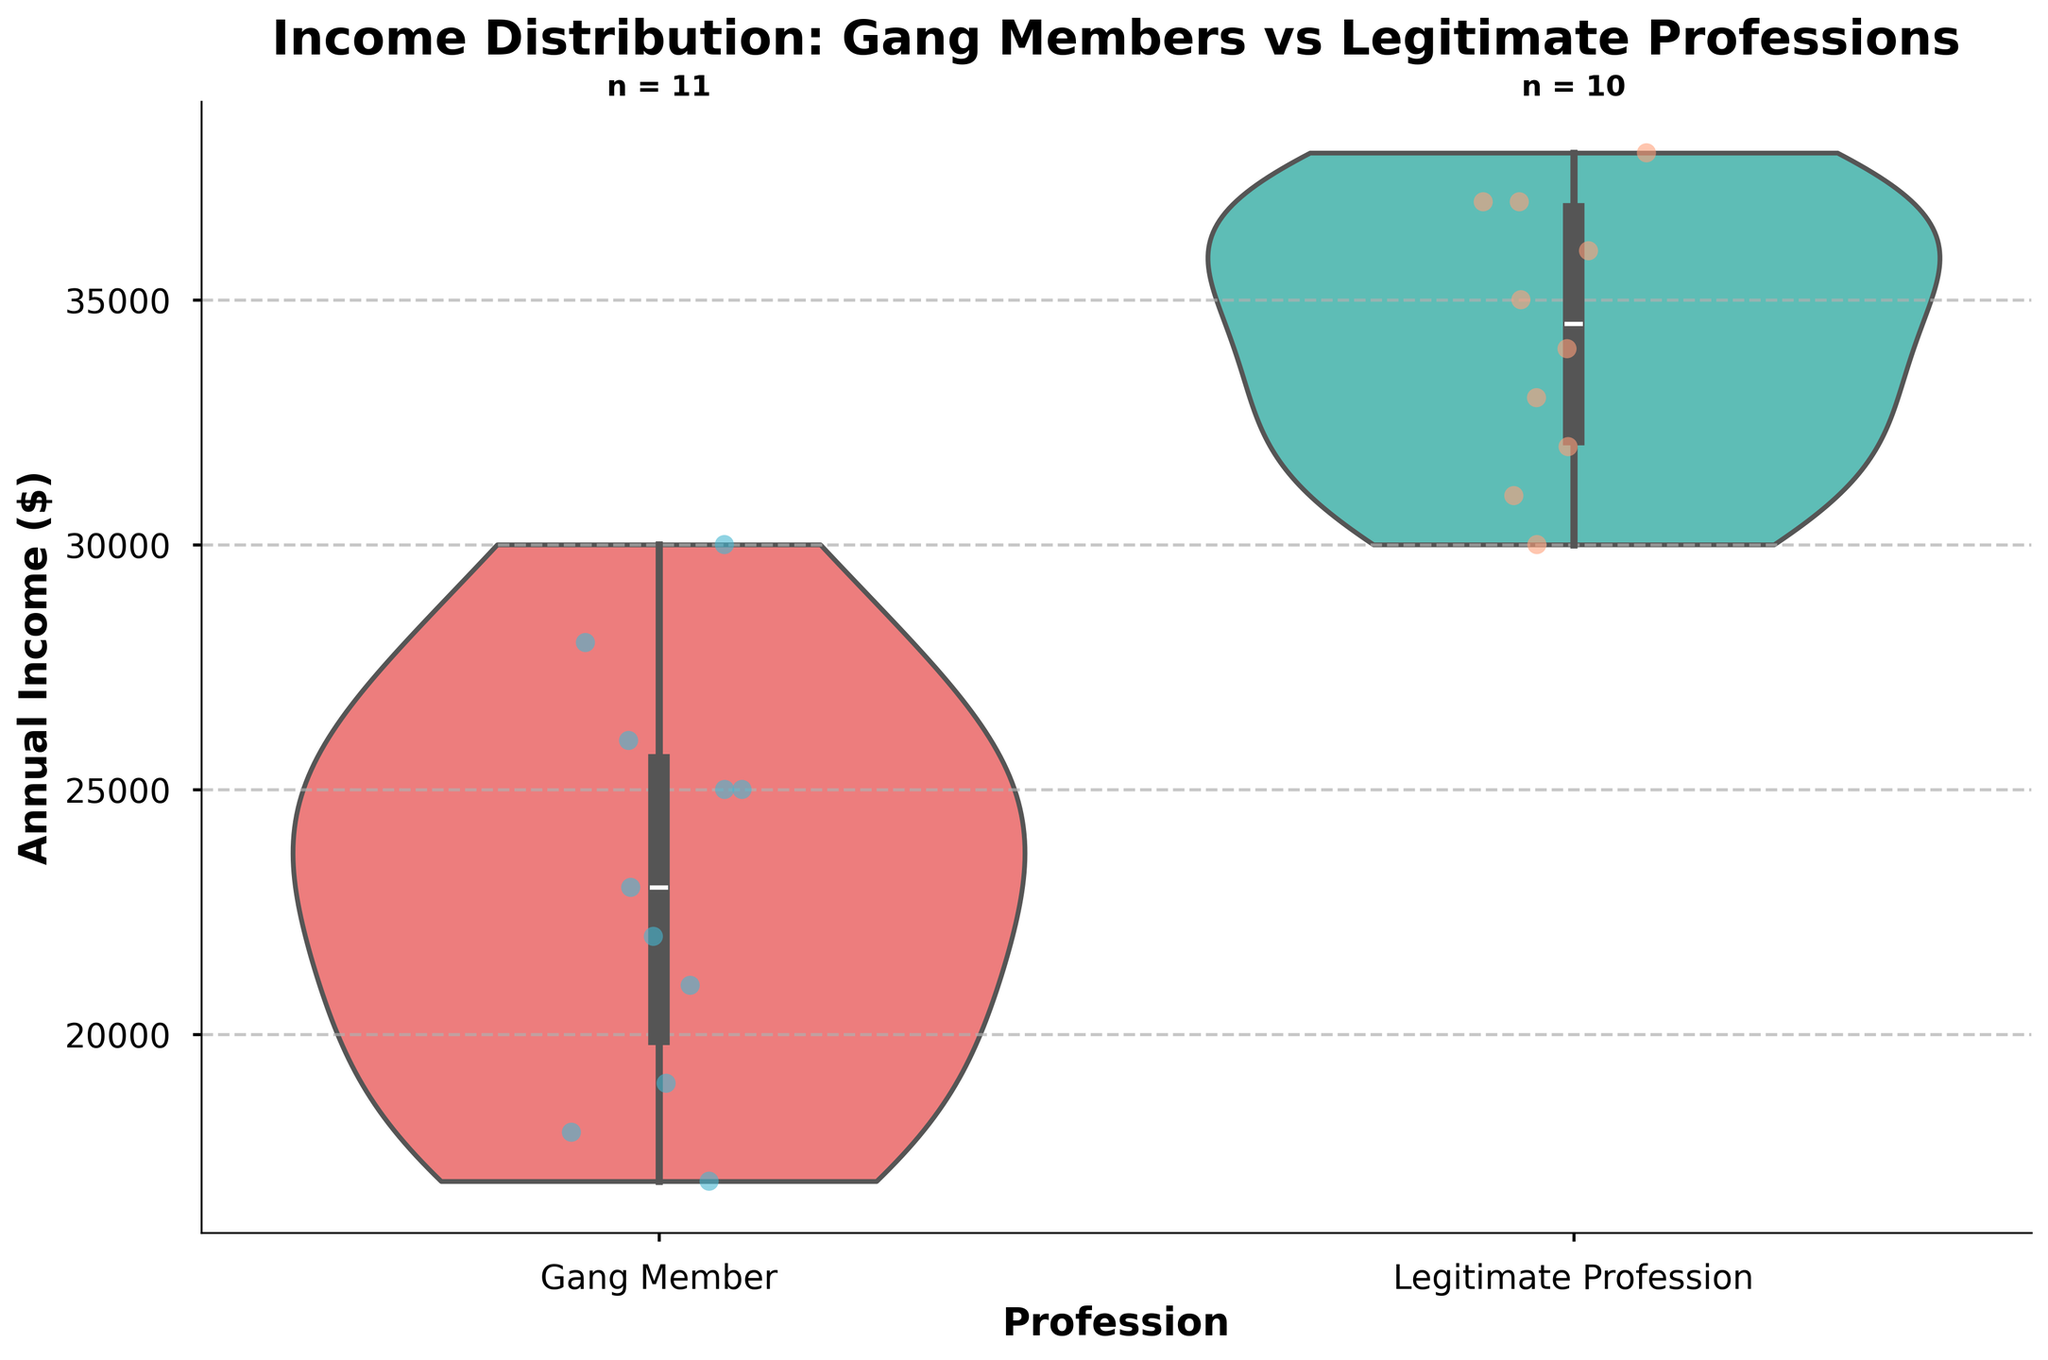What is the title of the figure? The title of the figure is displayed at the top and reads "Income Distribution: Gang Members vs Legitimate Professions".
Answer: Income Distribution: Gang Members vs Legitimate Professions Which profession has a wider spread of annual income, gang members or legitimate professions? By examining the width of the violin plots, we can observe that the income distribution for gang members covers a wider range compared to the more concentrated spread of the legitimate professions.
Answer: Gang members How many gang members' incomes are visualized in the plot? There is a text inside the plot area that indicates the sample size. For gang members, it displays "n = 10".
Answer: 10 What is the median income of legitimate professionals? The median line within the violin plot for legitimate professions represents the median income. Visually, this line is slightly below $35,000.
Answer: About $34,000 Compare the highest income points between gang members and legitimate professions. Which group has a higher value? Both the individual data points and the extent of the violin plots indicate that the highest income for legitimate professions reaches around $38,000, whereas for gang members, it is around $30,000.
Answer: Legitimate professions Are the data points of gang members more dispersed than those of legitimate professions? By observing the jittered points on the plot, we can see that the gang members' data points are more spread out horizontally and vertically compared to those of legitimate professions, indicating greater dispersion.
Answer: Yes What are the colors used for the violin plots of gang members and legitimate professions? The color of the violin plot for gang members is a shade of red, while that for legitimate professions is a shade of green.
Answer: Red for gang members, green for legitimate professions What is the interquartile range (IQR) of the annual income for gang members? The interquartile range (IQR) is not directly plotted but can be inferred from the inner part of the violin plot. For gang members, it roughly spans from the first quartile at around $20,000 to the third quartile at around $26,000, IQR = $26,000 - $20,000.
Answer: About $6,000 Which income has a closer association with the median in legitimate professions: the lower quartile or the upper quartile? Observing the inner box in the violin plot for legitimate professions, we can see that the upper quartile (around $37,000) is closer to the median (approximately $34,000) compared to the lower quartile (around $31,000).
Answer: Upper quartile 